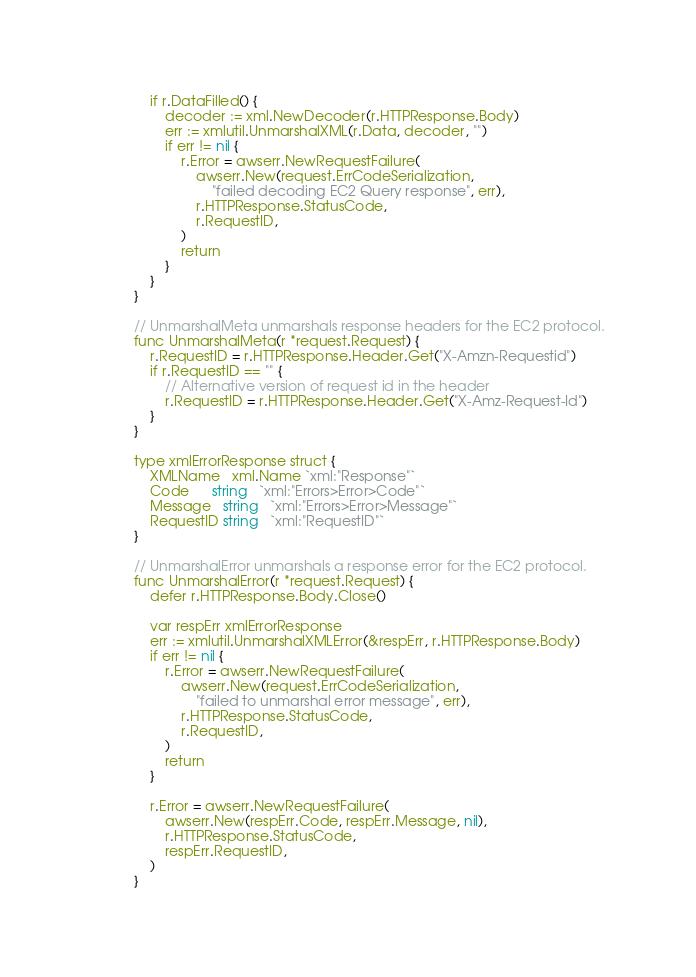<code> <loc_0><loc_0><loc_500><loc_500><_Go_>	if r.DataFilled() {
		decoder := xml.NewDecoder(r.HTTPResponse.Body)
		err := xmlutil.UnmarshalXML(r.Data, decoder, "")
		if err != nil {
			r.Error = awserr.NewRequestFailure(
				awserr.New(request.ErrCodeSerialization,
					"failed decoding EC2 Query response", err),
				r.HTTPResponse.StatusCode,
				r.RequestID,
			)
			return
		}
	}
}

// UnmarshalMeta unmarshals response headers for the EC2 protocol.
func UnmarshalMeta(r *request.Request) {
	r.RequestID = r.HTTPResponse.Header.Get("X-Amzn-Requestid")
	if r.RequestID == "" {
		// Alternative version of request id in the header
		r.RequestID = r.HTTPResponse.Header.Get("X-Amz-Request-Id")
	}
}

type xmlErrorResponse struct {
	XMLName   xml.Name `xml:"Response"`
	Code      string   `xml:"Errors>Error>Code"`
	Message   string   `xml:"Errors>Error>Message"`
	RequestID string   `xml:"RequestID"`
}

// UnmarshalError unmarshals a response error for the EC2 protocol.
func UnmarshalError(r *request.Request) {
	defer r.HTTPResponse.Body.Close()

	var respErr xmlErrorResponse
	err := xmlutil.UnmarshalXMLError(&respErr, r.HTTPResponse.Body)
	if err != nil {
		r.Error = awserr.NewRequestFailure(
			awserr.New(request.ErrCodeSerialization,
				"failed to unmarshal error message", err),
			r.HTTPResponse.StatusCode,
			r.RequestID,
		)
		return
	}

	r.Error = awserr.NewRequestFailure(
		awserr.New(respErr.Code, respErr.Message, nil),
		r.HTTPResponse.StatusCode,
		respErr.RequestID,
	)
}
</code> 